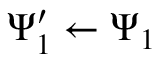Convert formula to latex. <formula><loc_0><loc_0><loc_500><loc_500>\Psi _ { 1 } ^ { \prime } \leftarrow \Psi _ { 1 }</formula> 